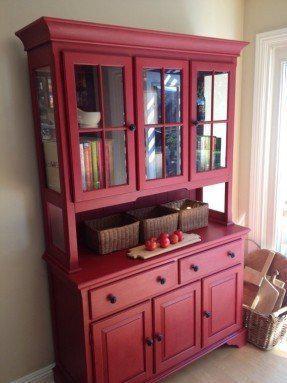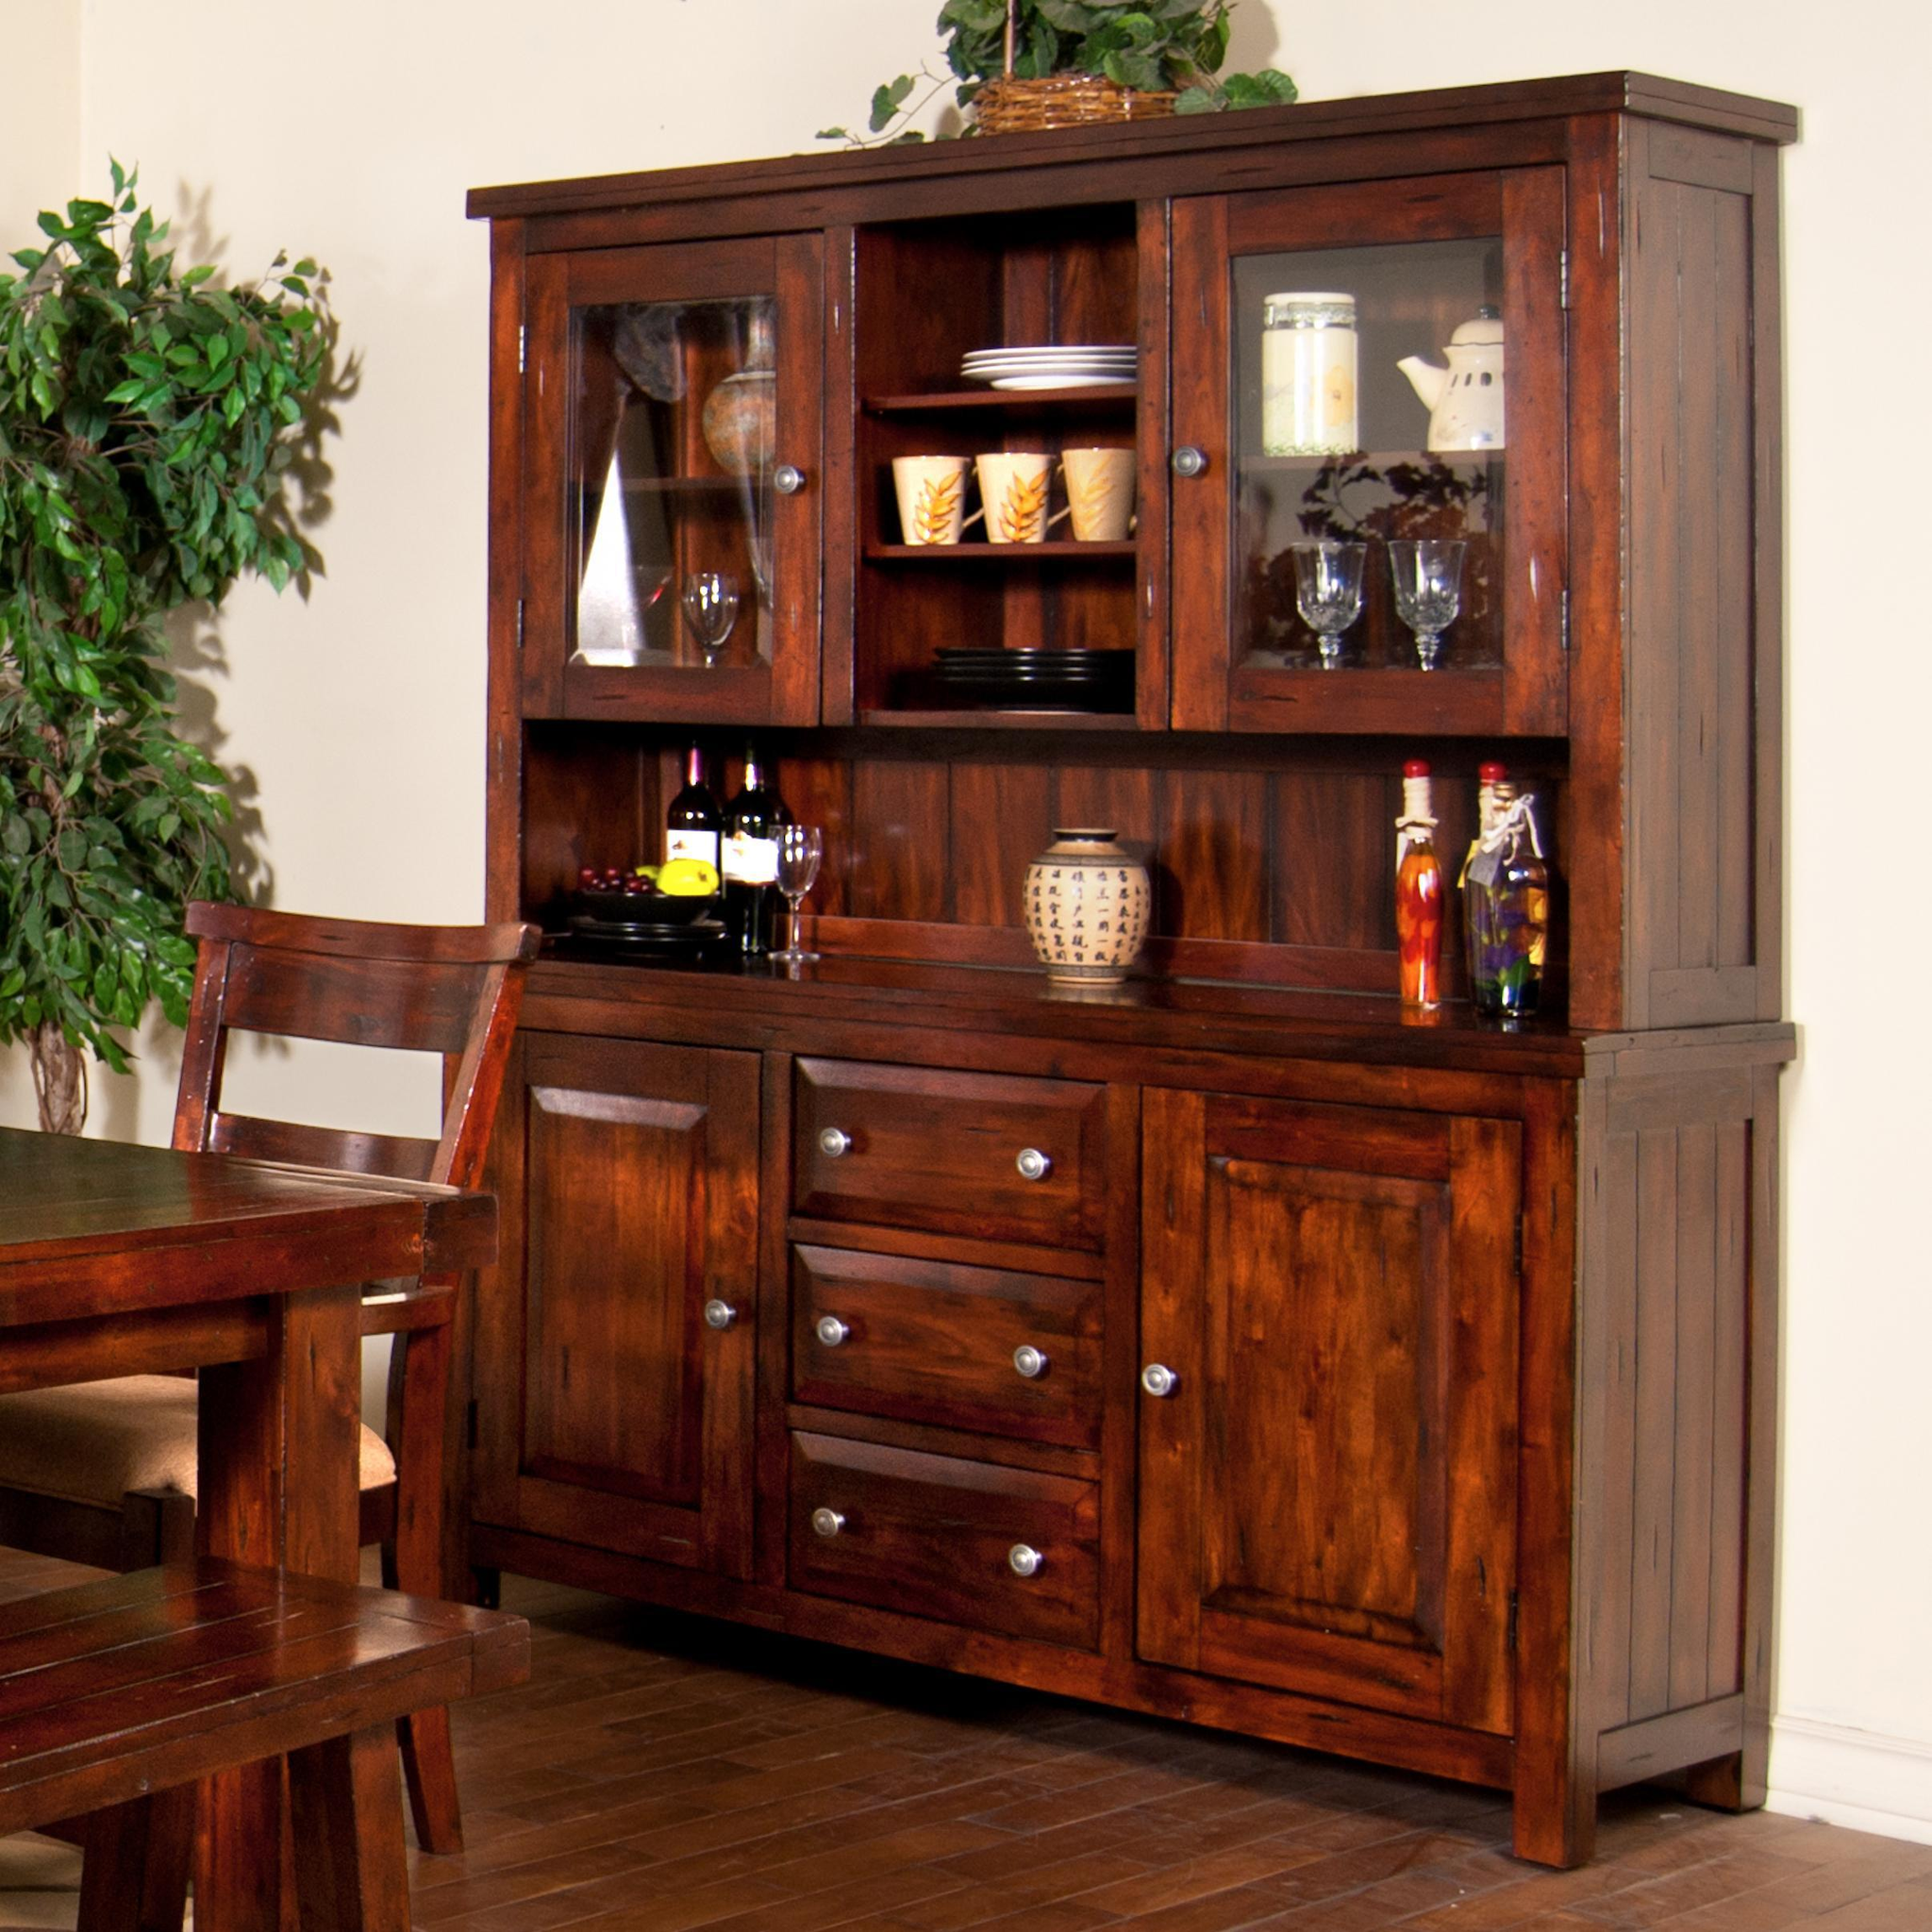The first image is the image on the left, the second image is the image on the right. For the images shown, is this caption "One of the cabinets has an arched, curved top, and both cabinets have some type of feet." true? Answer yes or no. No. The first image is the image on the left, the second image is the image on the right. For the images shown, is this caption "A wooden hutch in one image has a middle open section with three glass doors above, and a section with drawers and solid panel doors below." true? Answer yes or no. Yes. 